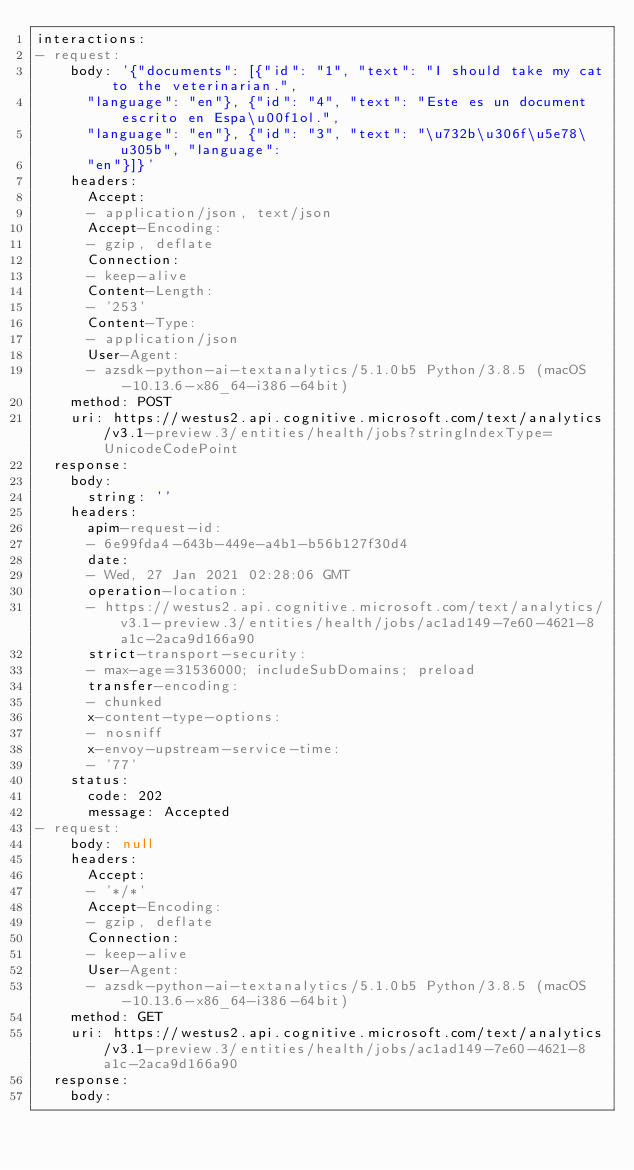Convert code to text. <code><loc_0><loc_0><loc_500><loc_500><_YAML_>interactions:
- request:
    body: '{"documents": [{"id": "1", "text": "I should take my cat to the veterinarian.",
      "language": "en"}, {"id": "4", "text": "Este es un document escrito en Espa\u00f1ol.",
      "language": "en"}, {"id": "3", "text": "\u732b\u306f\u5e78\u305b", "language":
      "en"}]}'
    headers:
      Accept:
      - application/json, text/json
      Accept-Encoding:
      - gzip, deflate
      Connection:
      - keep-alive
      Content-Length:
      - '253'
      Content-Type:
      - application/json
      User-Agent:
      - azsdk-python-ai-textanalytics/5.1.0b5 Python/3.8.5 (macOS-10.13.6-x86_64-i386-64bit)
    method: POST
    uri: https://westus2.api.cognitive.microsoft.com/text/analytics/v3.1-preview.3/entities/health/jobs?stringIndexType=UnicodeCodePoint
  response:
    body:
      string: ''
    headers:
      apim-request-id:
      - 6e99fda4-643b-449e-a4b1-b56b127f30d4
      date:
      - Wed, 27 Jan 2021 02:28:06 GMT
      operation-location:
      - https://westus2.api.cognitive.microsoft.com/text/analytics/v3.1-preview.3/entities/health/jobs/ac1ad149-7e60-4621-8a1c-2aca9d166a90
      strict-transport-security:
      - max-age=31536000; includeSubDomains; preload
      transfer-encoding:
      - chunked
      x-content-type-options:
      - nosniff
      x-envoy-upstream-service-time:
      - '77'
    status:
      code: 202
      message: Accepted
- request:
    body: null
    headers:
      Accept:
      - '*/*'
      Accept-Encoding:
      - gzip, deflate
      Connection:
      - keep-alive
      User-Agent:
      - azsdk-python-ai-textanalytics/5.1.0b5 Python/3.8.5 (macOS-10.13.6-x86_64-i386-64bit)
    method: GET
    uri: https://westus2.api.cognitive.microsoft.com/text/analytics/v3.1-preview.3/entities/health/jobs/ac1ad149-7e60-4621-8a1c-2aca9d166a90
  response:
    body:</code> 